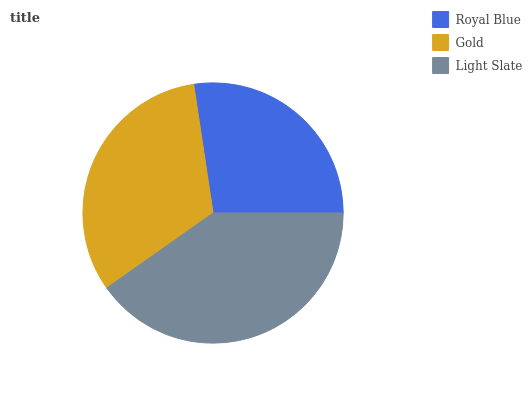Is Royal Blue the minimum?
Answer yes or no. Yes. Is Light Slate the maximum?
Answer yes or no. Yes. Is Gold the minimum?
Answer yes or no. No. Is Gold the maximum?
Answer yes or no. No. Is Gold greater than Royal Blue?
Answer yes or no. Yes. Is Royal Blue less than Gold?
Answer yes or no. Yes. Is Royal Blue greater than Gold?
Answer yes or no. No. Is Gold less than Royal Blue?
Answer yes or no. No. Is Gold the high median?
Answer yes or no. Yes. Is Gold the low median?
Answer yes or no. Yes. Is Royal Blue the high median?
Answer yes or no. No. Is Royal Blue the low median?
Answer yes or no. No. 